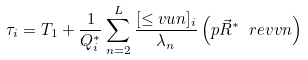<formula> <loc_0><loc_0><loc_500><loc_500>\tau _ { i } = T _ { 1 } + \frac { 1 } { Q _ { i } ^ { \ast } } \sum _ { n = 2 } ^ { L } \frac { [ \leq v { u } { n } ] _ { i } } { \lambda _ { n } } \left ( p { \vec { R } ^ { \ast } } { \ r e v { v } { n } } \right )</formula> 